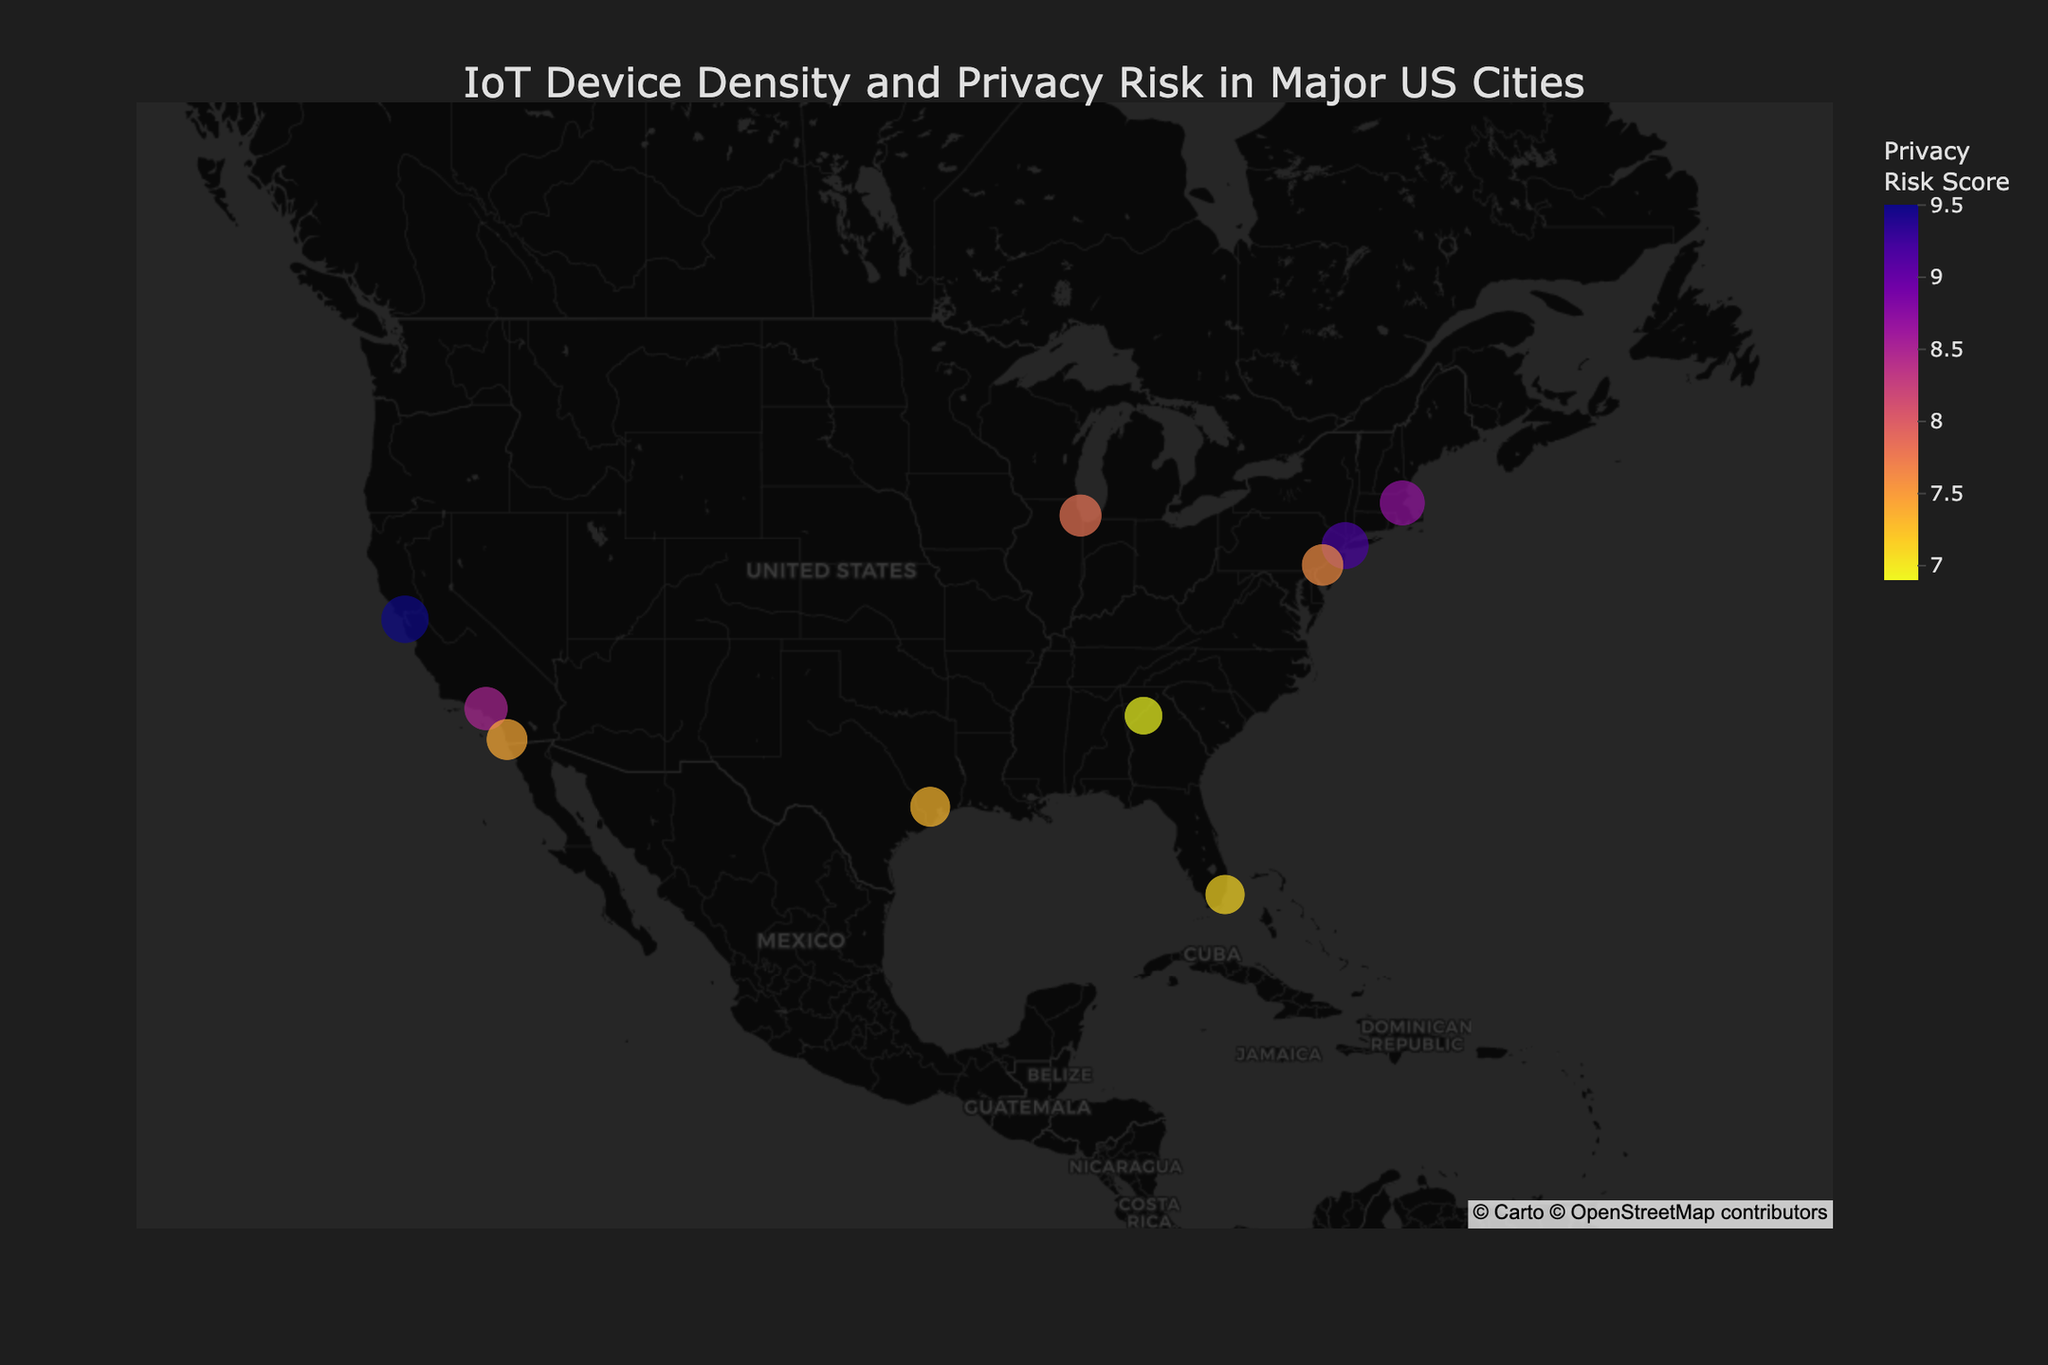How many cities are represented in the figure? The figure includes a point for each city. Count the number of distinct points/cities shown on the map.
Answer: 10 Which city has the highest IoT device density? Identify the city whose point on the map has the largest size, as larger sizes represent higher IoT device densities.
Answer: San Francisco What is the privacy risk score for Los Angeles? Hover over the point representing Los Angeles on the map to see the detailed information, including the privacy risk score.
Answer: 8.5 Compare the IoT device density between New York City and Miami. Which city has the higher density? Look at the size of the points for New York City and Miami. The point with the larger size represents the city with the higher IoT device density.
Answer: New York City What is the main type of IoT device in Atlanta? Hover over the point representing Atlanta on the map to see the detailed information, including the main type of IoT device.
Answer: Smart Traffic Lights Which city has the lowest privacy risk score? Identify the city with the point colored in the lowest value on the privacy risk color scale (Plasma_r).
Answer: Miami What is the average privacy risk score for all the cities? Add up all the privacy risk scores for each city (9.2 + 8.5 + 7.8 + 7.3 + 6.9 + 8.7 + 9.5 + 7.6 + 7.4 + 7.1) and divide by the number of cities (10).
Answer: 8.00 Compare the main IoT device types in Chicago and Philadelphia. Are they the same? Hover over the points representing Chicago and Philadelphia to see the detailed information, comparing the main IoT device types in both cities.
Answer: No How does the privacy risk score of Smart Home Devices in Boston compare to that of Wearable Tech in San Francisco? Hover over the points for Boston and San Francisco, then compare the privacy risk scores shown in the hover data.
Answer: San Francisco is higher Which city has a higher IoT density: Houston or San Diego? Look at the size of the points for Houston and San Diego. The point with the larger size represents the city with the higher IoT device density.
Answer: San Diego 